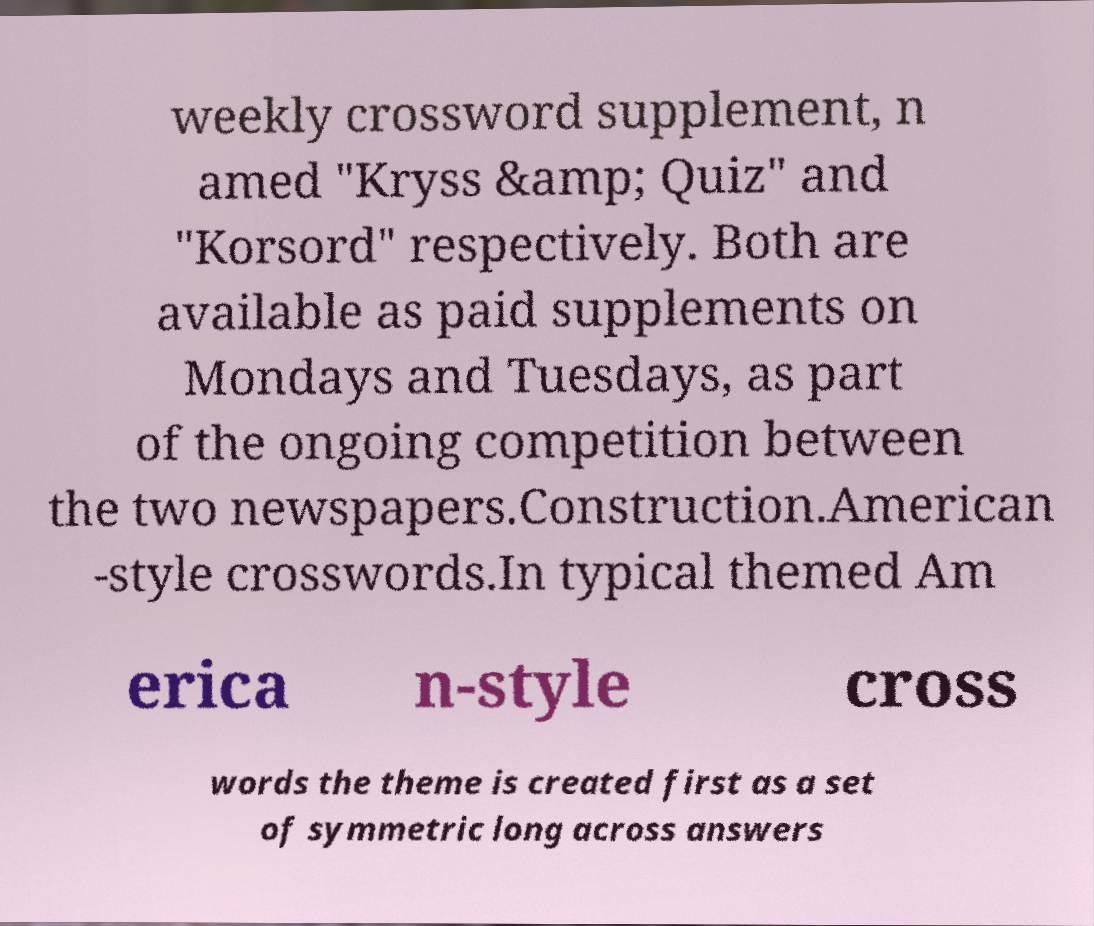Could you assist in decoding the text presented in this image and type it out clearly? weekly crossword supplement, n amed "Kryss &amp; Quiz" and "Korsord" respectively. Both are available as paid supplements on Mondays and Tuesdays, as part of the ongoing competition between the two newspapers.Construction.American -style crosswords.In typical themed Am erica n-style cross words the theme is created first as a set of symmetric long across answers 